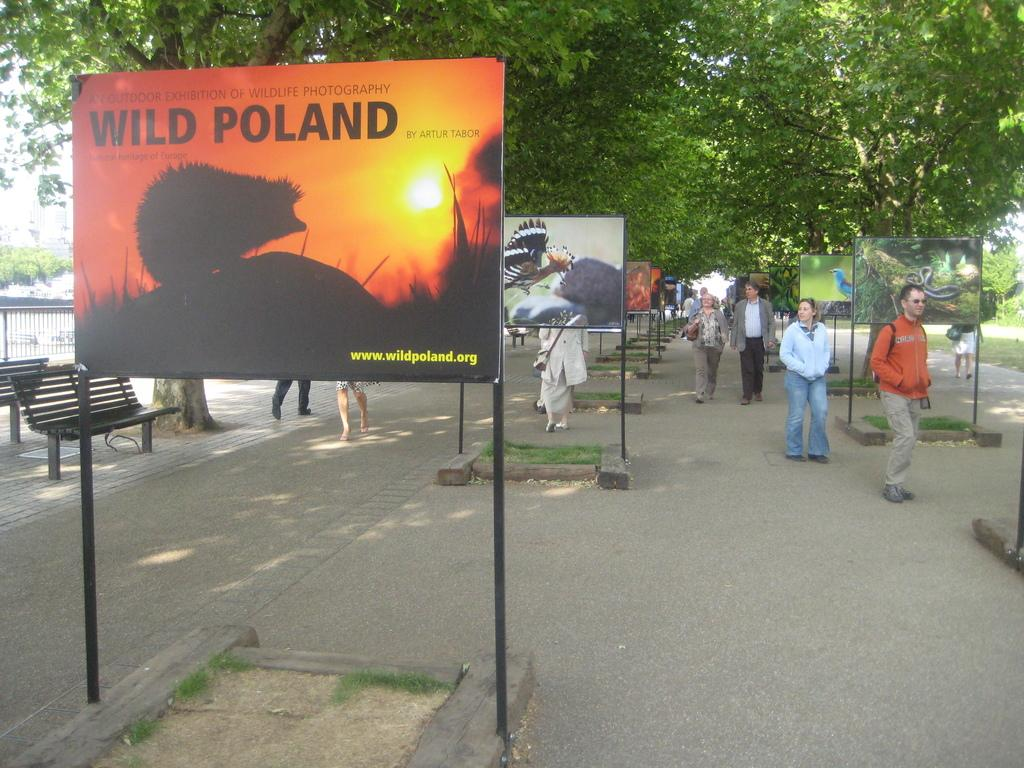<image>
Share a concise interpretation of the image provided. A few people walk down a sidewalk where a sign promotes a photography exhibition. 